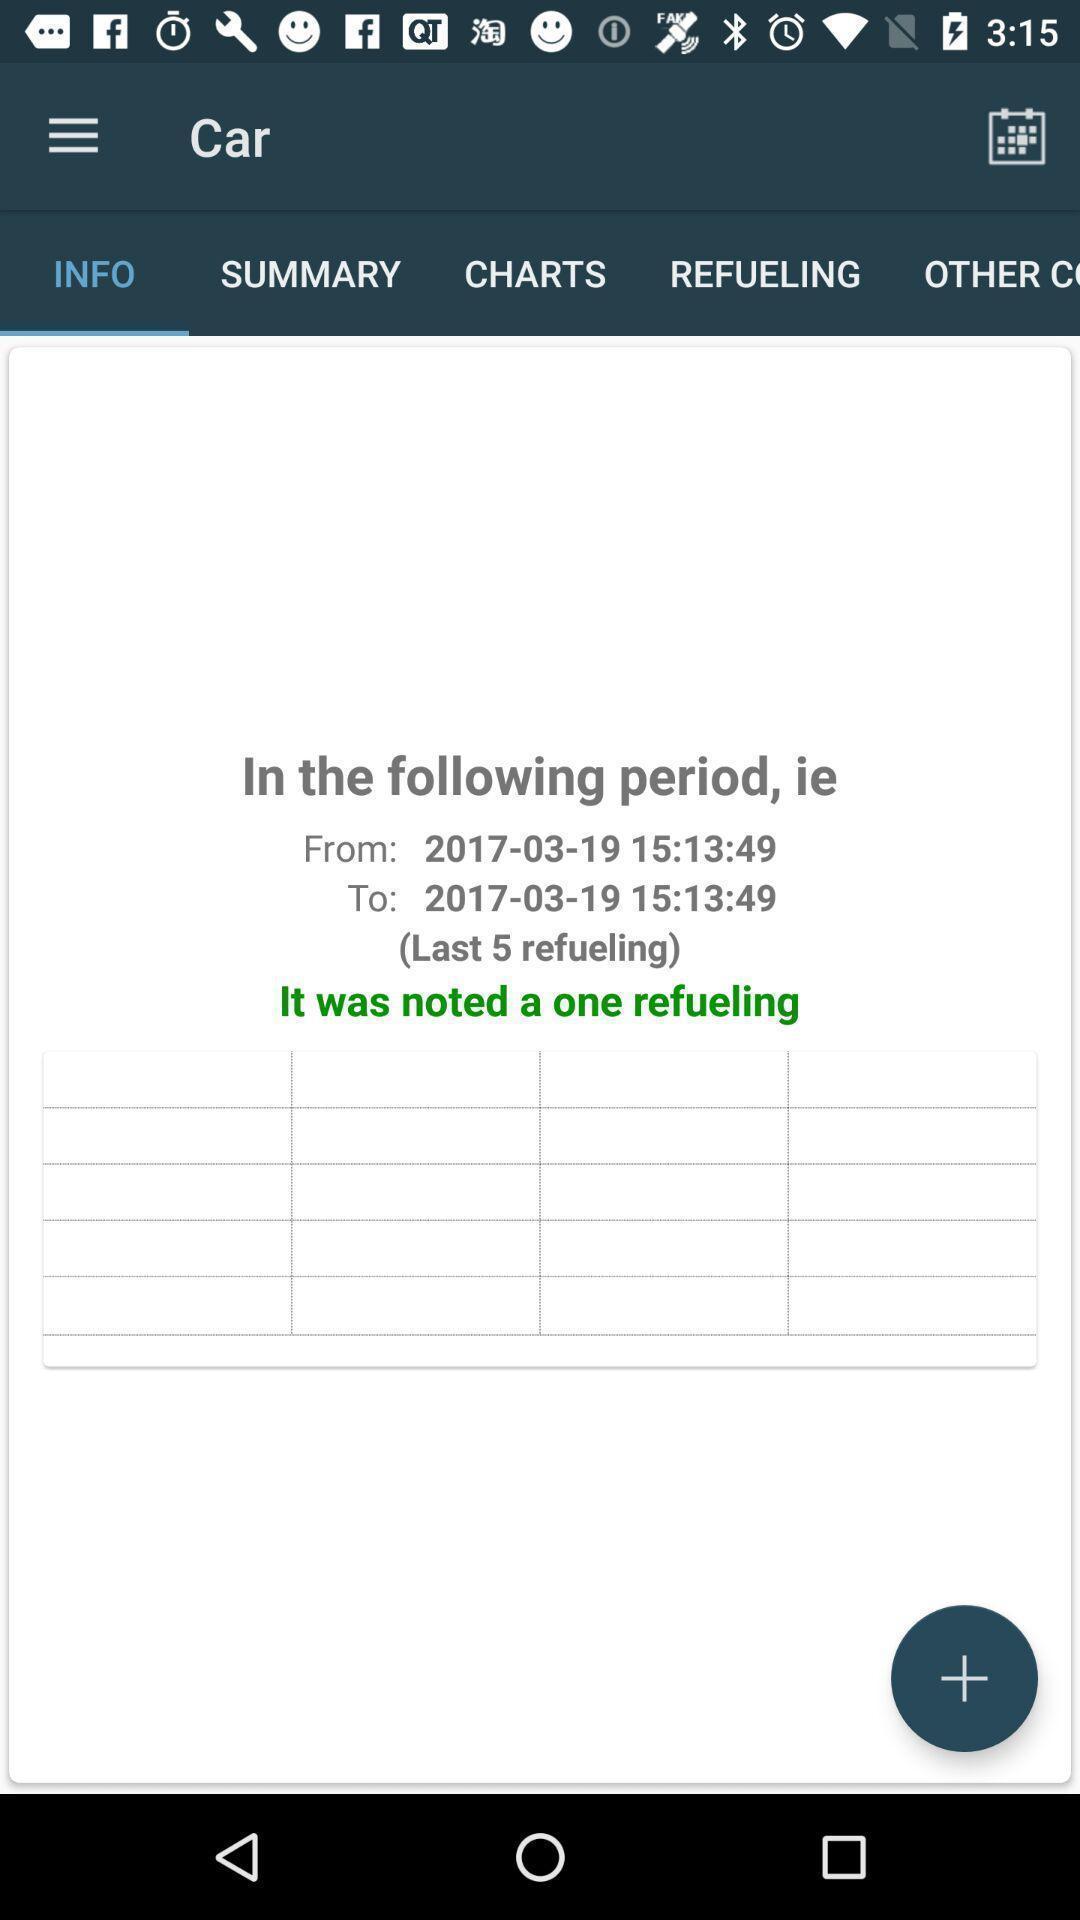What is the overall content of this screenshot? Page showing information of date. 